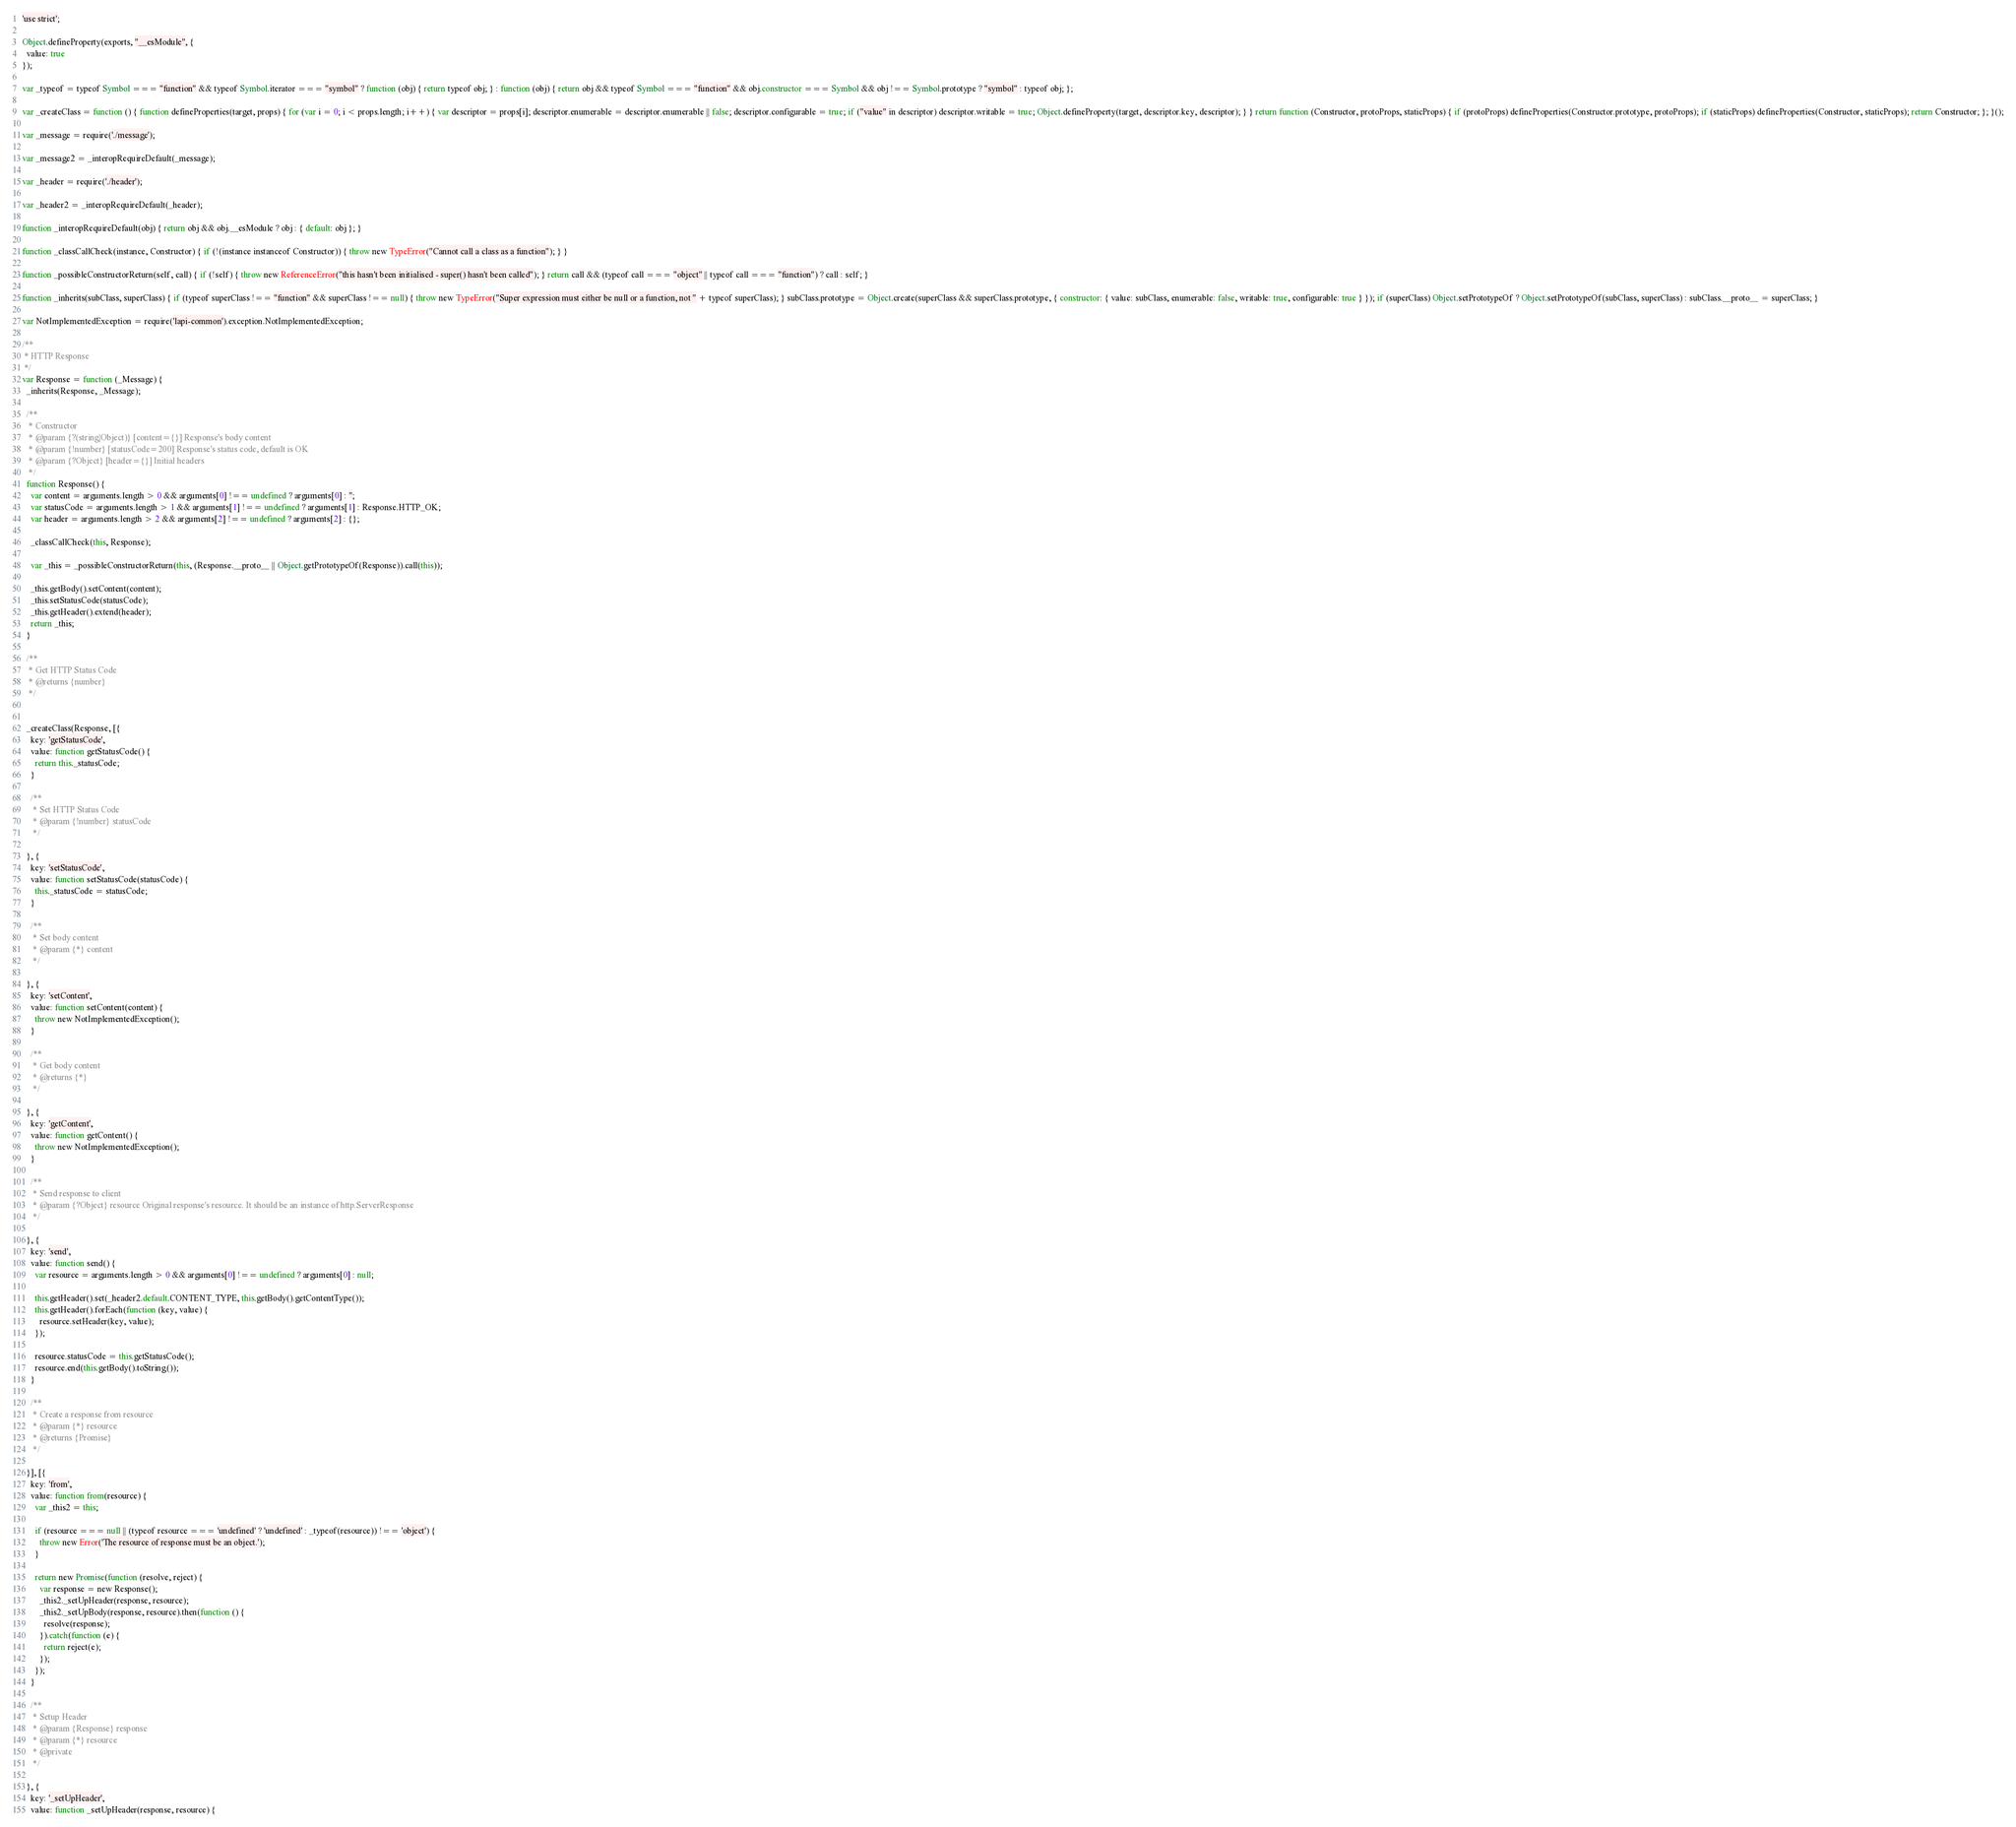Convert code to text. <code><loc_0><loc_0><loc_500><loc_500><_JavaScript_>'use strict';

Object.defineProperty(exports, "__esModule", {
  value: true
});

var _typeof = typeof Symbol === "function" && typeof Symbol.iterator === "symbol" ? function (obj) { return typeof obj; } : function (obj) { return obj && typeof Symbol === "function" && obj.constructor === Symbol && obj !== Symbol.prototype ? "symbol" : typeof obj; };

var _createClass = function () { function defineProperties(target, props) { for (var i = 0; i < props.length; i++) { var descriptor = props[i]; descriptor.enumerable = descriptor.enumerable || false; descriptor.configurable = true; if ("value" in descriptor) descriptor.writable = true; Object.defineProperty(target, descriptor.key, descriptor); } } return function (Constructor, protoProps, staticProps) { if (protoProps) defineProperties(Constructor.prototype, protoProps); if (staticProps) defineProperties(Constructor, staticProps); return Constructor; }; }();

var _message = require('./message');

var _message2 = _interopRequireDefault(_message);

var _header = require('./header');

var _header2 = _interopRequireDefault(_header);

function _interopRequireDefault(obj) { return obj && obj.__esModule ? obj : { default: obj }; }

function _classCallCheck(instance, Constructor) { if (!(instance instanceof Constructor)) { throw new TypeError("Cannot call a class as a function"); } }

function _possibleConstructorReturn(self, call) { if (!self) { throw new ReferenceError("this hasn't been initialised - super() hasn't been called"); } return call && (typeof call === "object" || typeof call === "function") ? call : self; }

function _inherits(subClass, superClass) { if (typeof superClass !== "function" && superClass !== null) { throw new TypeError("Super expression must either be null or a function, not " + typeof superClass); } subClass.prototype = Object.create(superClass && superClass.prototype, { constructor: { value: subClass, enumerable: false, writable: true, configurable: true } }); if (superClass) Object.setPrototypeOf ? Object.setPrototypeOf(subClass, superClass) : subClass.__proto__ = superClass; }

var NotImplementedException = require('lapi-common').exception.NotImplementedException;

/**
 * HTTP Response
 */
var Response = function (_Message) {
  _inherits(Response, _Message);

  /**
   * Constructor
   * @param {?(string|Object)} [content={}] Response's body content
   * @param {!number} [statusCode=200] Response's status code, default is OK
   * @param {?Object} [header={}] Initial headers
   */
  function Response() {
    var content = arguments.length > 0 && arguments[0] !== undefined ? arguments[0] : '';
    var statusCode = arguments.length > 1 && arguments[1] !== undefined ? arguments[1] : Response.HTTP_OK;
    var header = arguments.length > 2 && arguments[2] !== undefined ? arguments[2] : {};

    _classCallCheck(this, Response);

    var _this = _possibleConstructorReturn(this, (Response.__proto__ || Object.getPrototypeOf(Response)).call(this));

    _this.getBody().setContent(content);
    _this.setStatusCode(statusCode);
    _this.getHeader().extend(header);
    return _this;
  }

  /**
   * Get HTTP Status Code
   * @returns {number}
   */


  _createClass(Response, [{
    key: 'getStatusCode',
    value: function getStatusCode() {
      return this._statusCode;
    }

    /**
     * Set HTTP Status Code
     * @param {!number} statusCode
     */

  }, {
    key: 'setStatusCode',
    value: function setStatusCode(statusCode) {
      this._statusCode = statusCode;
    }

    /**
     * Set body content
     * @param {*} content
     */

  }, {
    key: 'setContent',
    value: function setContent(content) {
      throw new NotImplementedException();
    }

    /**
     * Get body content
     * @returns {*}
     */

  }, {
    key: 'getContent',
    value: function getContent() {
      throw new NotImplementedException();
    }

    /**
     * Send response to client
     * @param {?Object} resource Original response's resource. It should be an instance of http.ServerResponse
     */

  }, {
    key: 'send',
    value: function send() {
      var resource = arguments.length > 0 && arguments[0] !== undefined ? arguments[0] : null;

      this.getHeader().set(_header2.default.CONTENT_TYPE, this.getBody().getContentType());
      this.getHeader().forEach(function (key, value) {
        resource.setHeader(key, value);
      });

      resource.statusCode = this.getStatusCode();
      resource.end(this.getBody().toString());
    }

    /**
     * Create a response from resource
     * @param {*} resource
     * @returns {Promise}
     */

  }], [{
    key: 'from',
    value: function from(resource) {
      var _this2 = this;

      if (resource === null || (typeof resource === 'undefined' ? 'undefined' : _typeof(resource)) !== 'object') {
        throw new Error('The resource of response must be an object.');
      }

      return new Promise(function (resolve, reject) {
        var response = new Response();
        _this2._setUpHeader(response, resource);
        _this2._setUpBody(response, resource).then(function () {
          resolve(response);
        }).catch(function (e) {
          return reject(e);
        });
      });
    }

    /**
     * Setup Header
     * @param {Response} response
     * @param {*} resource
     * @private
     */

  }, {
    key: '_setUpHeader',
    value: function _setUpHeader(response, resource) {</code> 